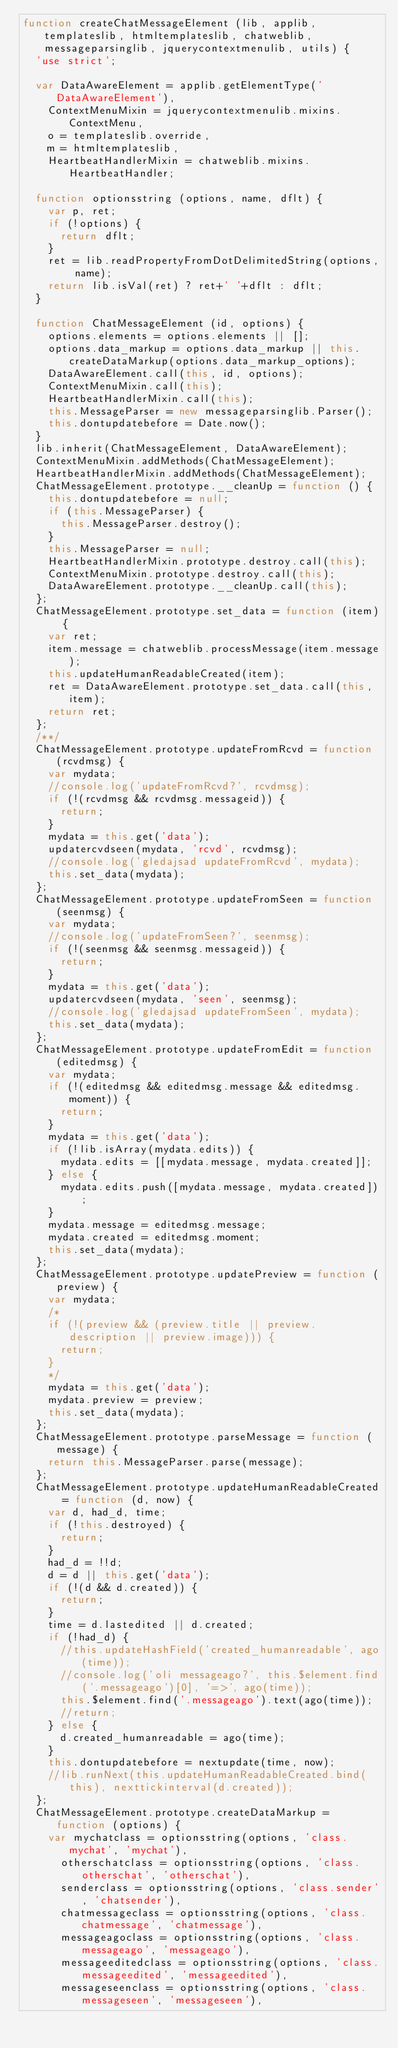<code> <loc_0><loc_0><loc_500><loc_500><_JavaScript_>function createChatMessageElement (lib, applib, templateslib, htmltemplateslib, chatweblib, messageparsinglib, jquerycontextmenulib, utils) {
  'use strict';

  var DataAwareElement = applib.getElementType('DataAwareElement'),
    ContextMenuMixin = jquerycontextmenulib.mixins.ContextMenu,
    o = templateslib.override,
    m = htmltemplateslib,
    HeartbeatHandlerMixin = chatweblib.mixins.HeartbeatHandler;

  function optionsstring (options, name, dflt) {
    var p, ret;
    if (!options) {
      return dflt;
    }
    ret = lib.readPropertyFromDotDelimitedString(options, name);
    return lib.isVal(ret) ? ret+' '+dflt : dflt;
  }
  
  function ChatMessageElement (id, options) {
    options.elements = options.elements || [];
    options.data_markup = options.data_markup || this.createDataMarkup(options.data_markup_options);
    DataAwareElement.call(this, id, options);
    ContextMenuMixin.call(this);
    HeartbeatHandlerMixin.call(this);
    this.MessageParser = new messageparsinglib.Parser();
    this.dontupdatebefore = Date.now();
  }
  lib.inherit(ChatMessageElement, DataAwareElement);
  ContextMenuMixin.addMethods(ChatMessageElement);
  HeartbeatHandlerMixin.addMethods(ChatMessageElement);
  ChatMessageElement.prototype.__cleanUp = function () {
    this.dontupdatebefore = null;
    if (this.MessageParser) {
      this.MessageParser.destroy();
    }
    this.MessageParser = null;
    HeartbeatHandlerMixin.prototype.destroy.call(this);
    ContextMenuMixin.prototype.destroy.call(this);
    DataAwareElement.prototype.__cleanUp.call(this);
  };
  ChatMessageElement.prototype.set_data = function (item) {
    var ret;
    item.message = chatweblib.processMessage(item.message);
    this.updateHumanReadableCreated(item);
    ret = DataAwareElement.prototype.set_data.call(this, item);
    return ret;
  };
  /**/
  ChatMessageElement.prototype.updateFromRcvd = function (rcvdmsg) {
    var mydata;
    //console.log('updateFromRcvd?', rcvdmsg);
    if (!(rcvdmsg && rcvdmsg.messageid)) {
      return;
    }
    mydata = this.get('data');
    updatercvdseen(mydata, 'rcvd', rcvdmsg);
    //console.log('gledajsad updateFromRcvd', mydata);
    this.set_data(mydata);
  };
  ChatMessageElement.prototype.updateFromSeen = function (seenmsg) {
    var mydata;
    //console.log('updateFromSeen?', seenmsg);
    if (!(seenmsg && seenmsg.messageid)) {
      return;
    }
    mydata = this.get('data');
    updatercvdseen(mydata, 'seen', seenmsg);
    //console.log('gledajsad updateFromSeen', mydata);
    this.set_data(mydata);
  };
  ChatMessageElement.prototype.updateFromEdit = function (editedmsg) {
    var mydata;
    if (!(editedmsg && editedmsg.message && editedmsg.moment)) {
      return;
    }
    mydata = this.get('data');
    if (!lib.isArray(mydata.edits)) {
      mydata.edits = [[mydata.message, mydata.created]];
    } else {
      mydata.edits.push([mydata.message, mydata.created]);
    }
    mydata.message = editedmsg.message;
    mydata.created = editedmsg.moment;
    this.set_data(mydata);
  };
  ChatMessageElement.prototype.updatePreview = function (preview) {
    var mydata;
    /*
    if (!(preview && (preview.title || preview.description || preview.image))) {
      return;
    }
    */
    mydata = this.get('data');
    mydata.preview = preview;
    this.set_data(mydata);
  };
  ChatMessageElement.prototype.parseMessage = function (message) {
    return this.MessageParser.parse(message);
  };
  ChatMessageElement.prototype.updateHumanReadableCreated = function (d, now) {
    var d, had_d, time;
    if (!this.destroyed) {
      return;
    }
    had_d = !!d;
    d = d || this.get('data');
    if (!(d && d.created)) {
      return;
    }
    time = d.lastedited || d.created;
    if (!had_d) {
      //this.updateHashField('created_humanreadable', ago(time));
      //console.log('oli messageago?', this.$element.find('.messageago')[0], '=>', ago(time));
      this.$element.find('.messageago').text(ago(time));
      //return;
    } else {
      d.created_humanreadable = ago(time);
    }
    this.dontupdatebefore = nextupdate(time, now);
    //lib.runNext(this.updateHumanReadableCreated.bind(this), nexttickinterval(d.created));
  };
  ChatMessageElement.prototype.createDataMarkup = function (options) {
    var mychatclass = optionsstring(options, 'class.mychat', 'mychat'),
      otherschatclass = optionsstring(options, 'class.otherschat', 'otherschat'),
      senderclass = optionsstring(options, 'class.sender', 'chatsender'),
      chatmessageclass = optionsstring(options, 'class.chatmessage', 'chatmessage'),
      messageagoclass = optionsstring(options, 'class.messageago', 'messageago'),
      messageeditedclass = optionsstring(options, 'class.messageedited', 'messageedited'),
      messageseenclass = optionsstring(options, 'class.messageseen', 'messageseen'),</code> 